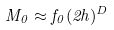<formula> <loc_0><loc_0><loc_500><loc_500>M _ { 0 } \approx f _ { 0 } ( 2 h ) ^ { D }</formula> 